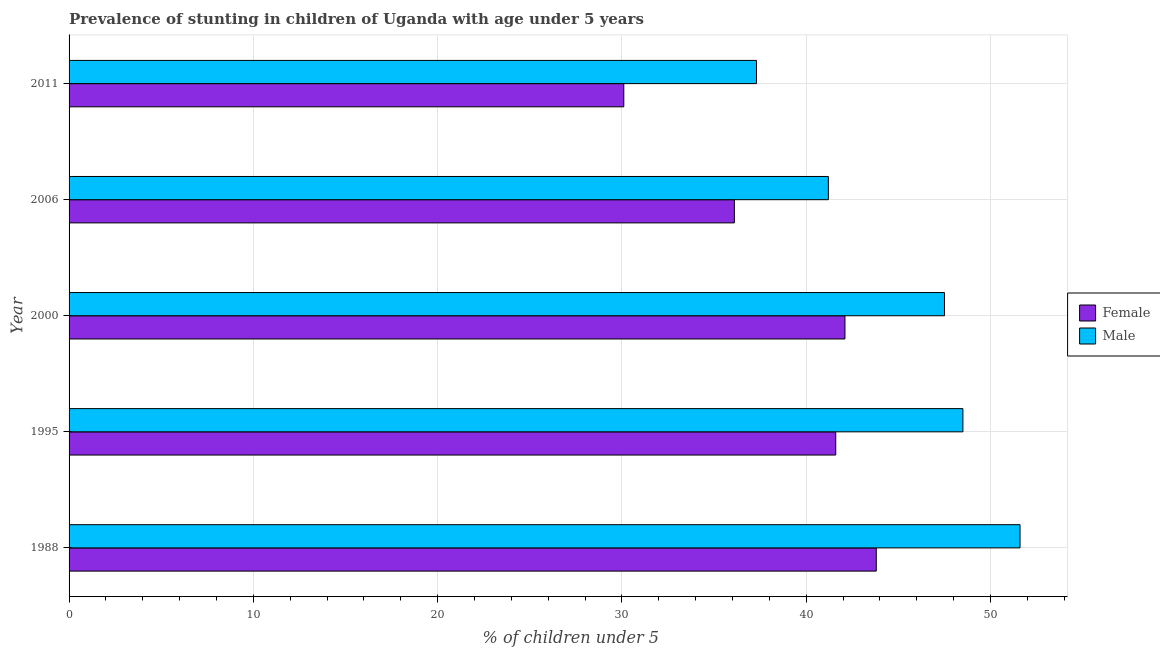How many groups of bars are there?
Your answer should be compact. 5. Are the number of bars per tick equal to the number of legend labels?
Ensure brevity in your answer.  Yes. How many bars are there on the 5th tick from the bottom?
Provide a succinct answer. 2. What is the label of the 3rd group of bars from the top?
Offer a terse response. 2000. In how many cases, is the number of bars for a given year not equal to the number of legend labels?
Offer a very short reply. 0. What is the percentage of stunted female children in 2000?
Offer a terse response. 42.1. Across all years, what is the maximum percentage of stunted female children?
Your response must be concise. 43.8. Across all years, what is the minimum percentage of stunted female children?
Offer a very short reply. 30.1. In which year was the percentage of stunted female children maximum?
Your response must be concise. 1988. In which year was the percentage of stunted male children minimum?
Provide a short and direct response. 2011. What is the total percentage of stunted female children in the graph?
Provide a succinct answer. 193.7. What is the difference between the percentage of stunted female children in 2000 and that in 2011?
Provide a succinct answer. 12. What is the difference between the percentage of stunted female children in 1988 and the percentage of stunted male children in 2011?
Your response must be concise. 6.5. What is the average percentage of stunted female children per year?
Offer a very short reply. 38.74. In how many years, is the percentage of stunted female children greater than 12 %?
Provide a succinct answer. 5. Is the percentage of stunted female children in 1995 less than that in 2000?
Provide a short and direct response. Yes. What is the difference between the highest and the second highest percentage of stunted female children?
Offer a terse response. 1.7. In how many years, is the percentage of stunted male children greater than the average percentage of stunted male children taken over all years?
Make the answer very short. 3. How many years are there in the graph?
Your answer should be compact. 5. What is the difference between two consecutive major ticks on the X-axis?
Provide a succinct answer. 10. Does the graph contain any zero values?
Keep it short and to the point. No. How many legend labels are there?
Give a very brief answer. 2. What is the title of the graph?
Ensure brevity in your answer.  Prevalence of stunting in children of Uganda with age under 5 years. What is the label or title of the X-axis?
Your response must be concise.  % of children under 5. What is the label or title of the Y-axis?
Offer a terse response. Year. What is the  % of children under 5 of Female in 1988?
Your answer should be compact. 43.8. What is the  % of children under 5 of Male in 1988?
Offer a very short reply. 51.6. What is the  % of children under 5 of Female in 1995?
Provide a short and direct response. 41.6. What is the  % of children under 5 of Male in 1995?
Provide a short and direct response. 48.5. What is the  % of children under 5 of Female in 2000?
Your response must be concise. 42.1. What is the  % of children under 5 in Male in 2000?
Provide a succinct answer. 47.5. What is the  % of children under 5 of Female in 2006?
Provide a short and direct response. 36.1. What is the  % of children under 5 of Male in 2006?
Offer a terse response. 41.2. What is the  % of children under 5 in Female in 2011?
Provide a short and direct response. 30.1. What is the  % of children under 5 in Male in 2011?
Your answer should be compact. 37.3. Across all years, what is the maximum  % of children under 5 in Female?
Offer a very short reply. 43.8. Across all years, what is the maximum  % of children under 5 in Male?
Offer a very short reply. 51.6. Across all years, what is the minimum  % of children under 5 of Female?
Provide a short and direct response. 30.1. Across all years, what is the minimum  % of children under 5 of Male?
Make the answer very short. 37.3. What is the total  % of children under 5 in Female in the graph?
Your answer should be compact. 193.7. What is the total  % of children under 5 in Male in the graph?
Provide a succinct answer. 226.1. What is the difference between the  % of children under 5 in Female in 1988 and that in 1995?
Your response must be concise. 2.2. What is the difference between the  % of children under 5 in Male in 1988 and that in 1995?
Your answer should be compact. 3.1. What is the difference between the  % of children under 5 of Female in 1988 and that in 2000?
Offer a terse response. 1.7. What is the difference between the  % of children under 5 in Female in 1988 and that in 2011?
Provide a succinct answer. 13.7. What is the difference between the  % of children under 5 of Male in 1988 and that in 2011?
Offer a terse response. 14.3. What is the difference between the  % of children under 5 of Male in 1995 and that in 2006?
Provide a succinct answer. 7.3. What is the difference between the  % of children under 5 of Female in 1995 and that in 2011?
Your response must be concise. 11.5. What is the difference between the  % of children under 5 of Female in 2000 and that in 2006?
Keep it short and to the point. 6. What is the difference between the  % of children under 5 in Male in 2000 and that in 2011?
Offer a very short reply. 10.2. What is the difference between the  % of children under 5 of Female in 1988 and the  % of children under 5 of Male in 2000?
Provide a short and direct response. -3.7. What is the difference between the  % of children under 5 of Female in 1988 and the  % of children under 5 of Male in 2006?
Provide a succinct answer. 2.6. What is the difference between the  % of children under 5 of Female in 1995 and the  % of children under 5 of Male in 2000?
Offer a very short reply. -5.9. What is the difference between the  % of children under 5 of Female in 1995 and the  % of children under 5 of Male in 2006?
Ensure brevity in your answer.  0.4. What is the difference between the  % of children under 5 in Female in 1995 and the  % of children under 5 in Male in 2011?
Offer a terse response. 4.3. What is the difference between the  % of children under 5 in Female in 2000 and the  % of children under 5 in Male in 2006?
Your response must be concise. 0.9. What is the difference between the  % of children under 5 in Female in 2000 and the  % of children under 5 in Male in 2011?
Your response must be concise. 4.8. What is the difference between the  % of children under 5 of Female in 2006 and the  % of children under 5 of Male in 2011?
Give a very brief answer. -1.2. What is the average  % of children under 5 of Female per year?
Your answer should be compact. 38.74. What is the average  % of children under 5 of Male per year?
Your response must be concise. 45.22. In the year 2000, what is the difference between the  % of children under 5 in Female and  % of children under 5 in Male?
Make the answer very short. -5.4. In the year 2011, what is the difference between the  % of children under 5 in Female and  % of children under 5 in Male?
Give a very brief answer. -7.2. What is the ratio of the  % of children under 5 of Female in 1988 to that in 1995?
Ensure brevity in your answer.  1.05. What is the ratio of the  % of children under 5 in Male in 1988 to that in 1995?
Give a very brief answer. 1.06. What is the ratio of the  % of children under 5 of Female in 1988 to that in 2000?
Keep it short and to the point. 1.04. What is the ratio of the  % of children under 5 of Male in 1988 to that in 2000?
Offer a very short reply. 1.09. What is the ratio of the  % of children under 5 of Female in 1988 to that in 2006?
Your response must be concise. 1.21. What is the ratio of the  % of children under 5 in Male in 1988 to that in 2006?
Ensure brevity in your answer.  1.25. What is the ratio of the  % of children under 5 of Female in 1988 to that in 2011?
Provide a succinct answer. 1.46. What is the ratio of the  % of children under 5 in Male in 1988 to that in 2011?
Ensure brevity in your answer.  1.38. What is the ratio of the  % of children under 5 of Male in 1995 to that in 2000?
Ensure brevity in your answer.  1.02. What is the ratio of the  % of children under 5 in Female in 1995 to that in 2006?
Ensure brevity in your answer.  1.15. What is the ratio of the  % of children under 5 of Male in 1995 to that in 2006?
Your answer should be compact. 1.18. What is the ratio of the  % of children under 5 in Female in 1995 to that in 2011?
Your answer should be compact. 1.38. What is the ratio of the  % of children under 5 in Male in 1995 to that in 2011?
Provide a succinct answer. 1.3. What is the ratio of the  % of children under 5 in Female in 2000 to that in 2006?
Provide a short and direct response. 1.17. What is the ratio of the  % of children under 5 in Male in 2000 to that in 2006?
Offer a terse response. 1.15. What is the ratio of the  % of children under 5 in Female in 2000 to that in 2011?
Your answer should be compact. 1.4. What is the ratio of the  % of children under 5 in Male in 2000 to that in 2011?
Make the answer very short. 1.27. What is the ratio of the  % of children under 5 in Female in 2006 to that in 2011?
Keep it short and to the point. 1.2. What is the ratio of the  % of children under 5 of Male in 2006 to that in 2011?
Ensure brevity in your answer.  1.1. What is the difference between the highest and the second highest  % of children under 5 of Male?
Provide a succinct answer. 3.1. What is the difference between the highest and the lowest  % of children under 5 in Female?
Give a very brief answer. 13.7. 